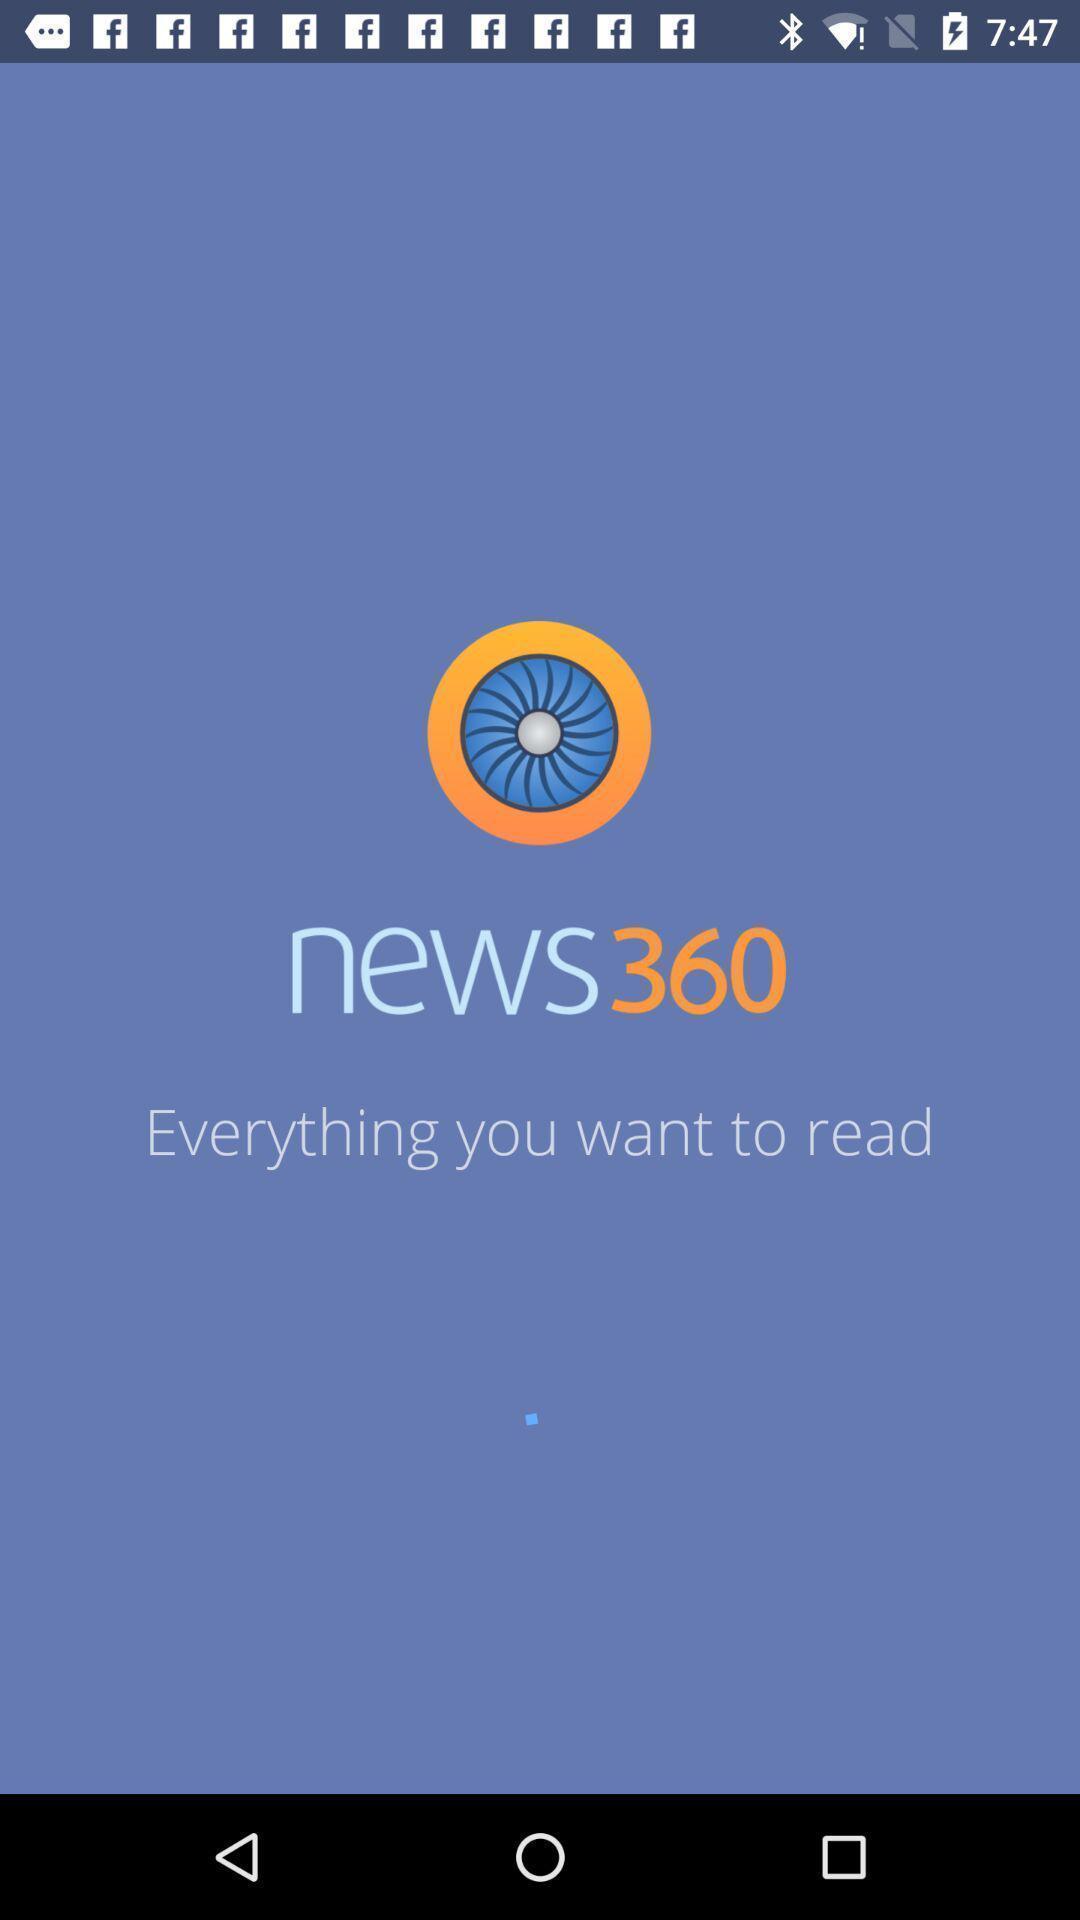Provide a description of this screenshot. Welcome page for the news application. 